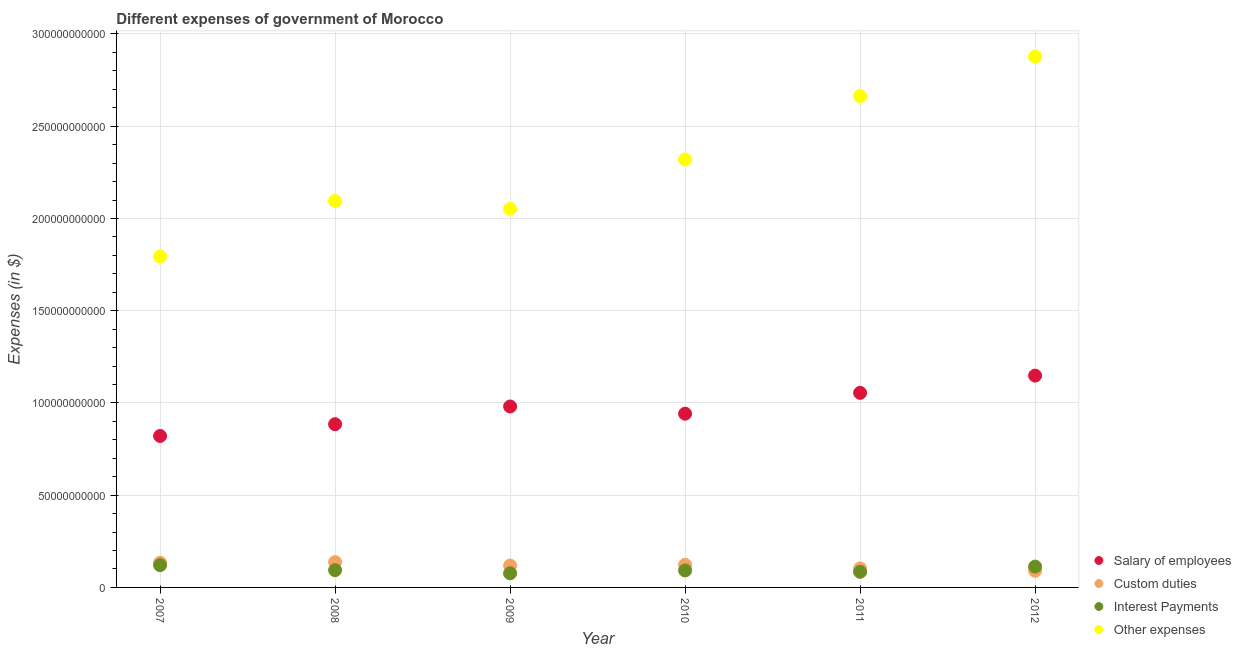Is the number of dotlines equal to the number of legend labels?
Keep it short and to the point. Yes. What is the amount spent on other expenses in 2009?
Provide a short and direct response. 2.05e+11. Across all years, what is the maximum amount spent on salary of employees?
Keep it short and to the point. 1.15e+11. Across all years, what is the minimum amount spent on salary of employees?
Give a very brief answer. 8.21e+1. In which year was the amount spent on other expenses maximum?
Provide a succinct answer. 2012. In which year was the amount spent on salary of employees minimum?
Provide a succinct answer. 2007. What is the total amount spent on interest payments in the graph?
Provide a succinct answer. 5.80e+1. What is the difference between the amount spent on custom duties in 2007 and that in 2012?
Ensure brevity in your answer.  4.41e+09. What is the difference between the amount spent on other expenses in 2007 and the amount spent on custom duties in 2010?
Your response must be concise. 1.67e+11. What is the average amount spent on other expenses per year?
Your response must be concise. 2.30e+11. In the year 2010, what is the difference between the amount spent on custom duties and amount spent on salary of employees?
Ensure brevity in your answer.  -8.19e+1. What is the ratio of the amount spent on interest payments in 2008 to that in 2009?
Keep it short and to the point. 1.22. Is the amount spent on other expenses in 2011 less than that in 2012?
Provide a short and direct response. Yes. Is the difference between the amount spent on salary of employees in 2009 and 2012 greater than the difference between the amount spent on custom duties in 2009 and 2012?
Provide a succinct answer. No. What is the difference between the highest and the second highest amount spent on custom duties?
Offer a very short reply. 2.91e+08. What is the difference between the highest and the lowest amount spent on salary of employees?
Provide a short and direct response. 3.27e+1. In how many years, is the amount spent on salary of employees greater than the average amount spent on salary of employees taken over all years?
Ensure brevity in your answer.  3. Is it the case that in every year, the sum of the amount spent on salary of employees and amount spent on custom duties is greater than the amount spent on interest payments?
Offer a terse response. Yes. Is the amount spent on salary of employees strictly less than the amount spent on custom duties over the years?
Your answer should be compact. No. How many dotlines are there?
Keep it short and to the point. 4. What is the difference between two consecutive major ticks on the Y-axis?
Provide a short and direct response. 5.00e+1. Are the values on the major ticks of Y-axis written in scientific E-notation?
Ensure brevity in your answer.  No. Does the graph contain any zero values?
Ensure brevity in your answer.  No. Does the graph contain grids?
Offer a very short reply. Yes. Where does the legend appear in the graph?
Keep it short and to the point. Bottom right. How are the legend labels stacked?
Ensure brevity in your answer.  Vertical. What is the title of the graph?
Make the answer very short. Different expenses of government of Morocco. What is the label or title of the Y-axis?
Offer a terse response. Expenses (in $). What is the Expenses (in $) in Salary of employees in 2007?
Your answer should be very brief. 8.21e+1. What is the Expenses (in $) in Custom duties in 2007?
Ensure brevity in your answer.  1.34e+1. What is the Expenses (in $) in Interest Payments in 2007?
Offer a terse response. 1.21e+1. What is the Expenses (in $) in Other expenses in 2007?
Offer a very short reply. 1.79e+11. What is the Expenses (in $) of Salary of employees in 2008?
Your response must be concise. 8.85e+1. What is the Expenses (in $) in Custom duties in 2008?
Give a very brief answer. 1.37e+1. What is the Expenses (in $) in Interest Payments in 2008?
Make the answer very short. 9.35e+09. What is the Expenses (in $) of Other expenses in 2008?
Your answer should be compact. 2.09e+11. What is the Expenses (in $) of Salary of employees in 2009?
Keep it short and to the point. 9.81e+1. What is the Expenses (in $) in Custom duties in 2009?
Keep it short and to the point. 1.18e+1. What is the Expenses (in $) of Interest Payments in 2009?
Your response must be concise. 7.66e+09. What is the Expenses (in $) of Other expenses in 2009?
Your answer should be compact. 2.05e+11. What is the Expenses (in $) of Salary of employees in 2010?
Make the answer very short. 9.42e+1. What is the Expenses (in $) in Custom duties in 2010?
Your answer should be very brief. 1.23e+1. What is the Expenses (in $) in Interest Payments in 2010?
Offer a very short reply. 9.21e+09. What is the Expenses (in $) of Other expenses in 2010?
Ensure brevity in your answer.  2.32e+11. What is the Expenses (in $) in Salary of employees in 2011?
Provide a succinct answer. 1.05e+11. What is the Expenses (in $) in Custom duties in 2011?
Your answer should be compact. 1.03e+1. What is the Expenses (in $) in Interest Payments in 2011?
Your answer should be very brief. 8.45e+09. What is the Expenses (in $) in Other expenses in 2011?
Your answer should be compact. 2.66e+11. What is the Expenses (in $) in Salary of employees in 2012?
Offer a very short reply. 1.15e+11. What is the Expenses (in $) of Custom duties in 2012?
Ensure brevity in your answer.  9.00e+09. What is the Expenses (in $) of Interest Payments in 2012?
Ensure brevity in your answer.  1.13e+1. What is the Expenses (in $) of Other expenses in 2012?
Your answer should be compact. 2.88e+11. Across all years, what is the maximum Expenses (in $) of Salary of employees?
Provide a short and direct response. 1.15e+11. Across all years, what is the maximum Expenses (in $) of Custom duties?
Ensure brevity in your answer.  1.37e+1. Across all years, what is the maximum Expenses (in $) of Interest Payments?
Keep it short and to the point. 1.21e+1. Across all years, what is the maximum Expenses (in $) of Other expenses?
Your answer should be compact. 2.88e+11. Across all years, what is the minimum Expenses (in $) of Salary of employees?
Provide a short and direct response. 8.21e+1. Across all years, what is the minimum Expenses (in $) in Custom duties?
Your answer should be very brief. 9.00e+09. Across all years, what is the minimum Expenses (in $) in Interest Payments?
Give a very brief answer. 7.66e+09. Across all years, what is the minimum Expenses (in $) in Other expenses?
Your response must be concise. 1.79e+11. What is the total Expenses (in $) of Salary of employees in the graph?
Your answer should be very brief. 5.83e+11. What is the total Expenses (in $) in Custom duties in the graph?
Keep it short and to the point. 7.05e+1. What is the total Expenses (in $) in Interest Payments in the graph?
Provide a short and direct response. 5.80e+1. What is the total Expenses (in $) in Other expenses in the graph?
Provide a short and direct response. 1.38e+12. What is the difference between the Expenses (in $) in Salary of employees in 2007 and that in 2008?
Keep it short and to the point. -6.37e+09. What is the difference between the Expenses (in $) of Custom duties in 2007 and that in 2008?
Give a very brief answer. -2.91e+08. What is the difference between the Expenses (in $) in Interest Payments in 2007 and that in 2008?
Provide a short and direct response. 2.71e+09. What is the difference between the Expenses (in $) of Other expenses in 2007 and that in 2008?
Offer a very short reply. -3.00e+1. What is the difference between the Expenses (in $) in Salary of employees in 2007 and that in 2009?
Your answer should be very brief. -1.60e+1. What is the difference between the Expenses (in $) of Custom duties in 2007 and that in 2009?
Offer a very short reply. 1.59e+09. What is the difference between the Expenses (in $) of Interest Payments in 2007 and that in 2009?
Provide a succinct answer. 4.40e+09. What is the difference between the Expenses (in $) in Other expenses in 2007 and that in 2009?
Your response must be concise. -2.57e+1. What is the difference between the Expenses (in $) in Salary of employees in 2007 and that in 2010?
Ensure brevity in your answer.  -1.21e+1. What is the difference between the Expenses (in $) of Custom duties in 2007 and that in 2010?
Keep it short and to the point. 1.15e+09. What is the difference between the Expenses (in $) in Interest Payments in 2007 and that in 2010?
Make the answer very short. 2.86e+09. What is the difference between the Expenses (in $) of Other expenses in 2007 and that in 2010?
Your response must be concise. -5.25e+1. What is the difference between the Expenses (in $) in Salary of employees in 2007 and that in 2011?
Your answer should be compact. -2.34e+1. What is the difference between the Expenses (in $) of Custom duties in 2007 and that in 2011?
Make the answer very short. 3.13e+09. What is the difference between the Expenses (in $) of Interest Payments in 2007 and that in 2011?
Make the answer very short. 3.61e+09. What is the difference between the Expenses (in $) in Other expenses in 2007 and that in 2011?
Make the answer very short. -8.69e+1. What is the difference between the Expenses (in $) of Salary of employees in 2007 and that in 2012?
Give a very brief answer. -3.27e+1. What is the difference between the Expenses (in $) of Custom duties in 2007 and that in 2012?
Provide a short and direct response. 4.41e+09. What is the difference between the Expenses (in $) in Interest Payments in 2007 and that in 2012?
Offer a terse response. 7.71e+08. What is the difference between the Expenses (in $) of Other expenses in 2007 and that in 2012?
Offer a very short reply. -1.08e+11. What is the difference between the Expenses (in $) in Salary of employees in 2008 and that in 2009?
Make the answer very short. -9.61e+09. What is the difference between the Expenses (in $) of Custom duties in 2008 and that in 2009?
Keep it short and to the point. 1.88e+09. What is the difference between the Expenses (in $) in Interest Payments in 2008 and that in 2009?
Offer a terse response. 1.69e+09. What is the difference between the Expenses (in $) of Other expenses in 2008 and that in 2009?
Your answer should be compact. 4.27e+09. What is the difference between the Expenses (in $) of Salary of employees in 2008 and that in 2010?
Your response must be concise. -5.70e+09. What is the difference between the Expenses (in $) in Custom duties in 2008 and that in 2010?
Make the answer very short. 1.44e+09. What is the difference between the Expenses (in $) of Interest Payments in 2008 and that in 2010?
Your response must be concise. 1.45e+08. What is the difference between the Expenses (in $) of Other expenses in 2008 and that in 2010?
Your answer should be compact. -2.25e+1. What is the difference between the Expenses (in $) in Salary of employees in 2008 and that in 2011?
Your answer should be compact. -1.70e+1. What is the difference between the Expenses (in $) of Custom duties in 2008 and that in 2011?
Make the answer very short. 3.42e+09. What is the difference between the Expenses (in $) in Interest Payments in 2008 and that in 2011?
Keep it short and to the point. 8.96e+08. What is the difference between the Expenses (in $) in Other expenses in 2008 and that in 2011?
Provide a short and direct response. -5.68e+1. What is the difference between the Expenses (in $) in Salary of employees in 2008 and that in 2012?
Your response must be concise. -2.63e+1. What is the difference between the Expenses (in $) of Custom duties in 2008 and that in 2012?
Provide a succinct answer. 4.70e+09. What is the difference between the Expenses (in $) of Interest Payments in 2008 and that in 2012?
Give a very brief answer. -1.94e+09. What is the difference between the Expenses (in $) in Other expenses in 2008 and that in 2012?
Give a very brief answer. -7.82e+1. What is the difference between the Expenses (in $) of Salary of employees in 2009 and that in 2010?
Your answer should be very brief. 3.92e+09. What is the difference between the Expenses (in $) of Custom duties in 2009 and that in 2010?
Offer a terse response. -4.39e+08. What is the difference between the Expenses (in $) in Interest Payments in 2009 and that in 2010?
Your answer should be compact. -1.54e+09. What is the difference between the Expenses (in $) in Other expenses in 2009 and that in 2010?
Offer a terse response. -2.68e+1. What is the difference between the Expenses (in $) in Salary of employees in 2009 and that in 2011?
Provide a succinct answer. -7.38e+09. What is the difference between the Expenses (in $) in Custom duties in 2009 and that in 2011?
Offer a terse response. 1.54e+09. What is the difference between the Expenses (in $) in Interest Payments in 2009 and that in 2011?
Offer a very short reply. -7.90e+08. What is the difference between the Expenses (in $) of Other expenses in 2009 and that in 2011?
Your answer should be compact. -6.11e+1. What is the difference between the Expenses (in $) of Salary of employees in 2009 and that in 2012?
Provide a succinct answer. -1.67e+1. What is the difference between the Expenses (in $) of Custom duties in 2009 and that in 2012?
Keep it short and to the point. 2.83e+09. What is the difference between the Expenses (in $) in Interest Payments in 2009 and that in 2012?
Keep it short and to the point. -3.63e+09. What is the difference between the Expenses (in $) of Other expenses in 2009 and that in 2012?
Provide a succinct answer. -8.25e+1. What is the difference between the Expenses (in $) of Salary of employees in 2010 and that in 2011?
Your response must be concise. -1.13e+1. What is the difference between the Expenses (in $) of Custom duties in 2010 and that in 2011?
Give a very brief answer. 1.98e+09. What is the difference between the Expenses (in $) of Interest Payments in 2010 and that in 2011?
Make the answer very short. 7.52e+08. What is the difference between the Expenses (in $) in Other expenses in 2010 and that in 2011?
Offer a very short reply. -3.44e+1. What is the difference between the Expenses (in $) in Salary of employees in 2010 and that in 2012?
Keep it short and to the point. -2.06e+1. What is the difference between the Expenses (in $) of Custom duties in 2010 and that in 2012?
Provide a succinct answer. 3.27e+09. What is the difference between the Expenses (in $) of Interest Payments in 2010 and that in 2012?
Your response must be concise. -2.08e+09. What is the difference between the Expenses (in $) in Other expenses in 2010 and that in 2012?
Make the answer very short. -5.57e+1. What is the difference between the Expenses (in $) in Salary of employees in 2011 and that in 2012?
Your answer should be compact. -9.35e+09. What is the difference between the Expenses (in $) of Custom duties in 2011 and that in 2012?
Your answer should be compact. 1.28e+09. What is the difference between the Expenses (in $) of Interest Payments in 2011 and that in 2012?
Your answer should be compact. -2.84e+09. What is the difference between the Expenses (in $) of Other expenses in 2011 and that in 2012?
Your response must be concise. -2.14e+1. What is the difference between the Expenses (in $) in Salary of employees in 2007 and the Expenses (in $) in Custom duties in 2008?
Your response must be concise. 6.84e+1. What is the difference between the Expenses (in $) in Salary of employees in 2007 and the Expenses (in $) in Interest Payments in 2008?
Make the answer very short. 7.27e+1. What is the difference between the Expenses (in $) in Salary of employees in 2007 and the Expenses (in $) in Other expenses in 2008?
Your answer should be compact. -1.27e+11. What is the difference between the Expenses (in $) of Custom duties in 2007 and the Expenses (in $) of Interest Payments in 2008?
Ensure brevity in your answer.  4.06e+09. What is the difference between the Expenses (in $) in Custom duties in 2007 and the Expenses (in $) in Other expenses in 2008?
Ensure brevity in your answer.  -1.96e+11. What is the difference between the Expenses (in $) in Interest Payments in 2007 and the Expenses (in $) in Other expenses in 2008?
Give a very brief answer. -1.97e+11. What is the difference between the Expenses (in $) of Salary of employees in 2007 and the Expenses (in $) of Custom duties in 2009?
Provide a short and direct response. 7.03e+1. What is the difference between the Expenses (in $) of Salary of employees in 2007 and the Expenses (in $) of Interest Payments in 2009?
Ensure brevity in your answer.  7.44e+1. What is the difference between the Expenses (in $) in Salary of employees in 2007 and the Expenses (in $) in Other expenses in 2009?
Give a very brief answer. -1.23e+11. What is the difference between the Expenses (in $) of Custom duties in 2007 and the Expenses (in $) of Interest Payments in 2009?
Your answer should be very brief. 5.75e+09. What is the difference between the Expenses (in $) in Custom duties in 2007 and the Expenses (in $) in Other expenses in 2009?
Give a very brief answer. -1.92e+11. What is the difference between the Expenses (in $) of Interest Payments in 2007 and the Expenses (in $) of Other expenses in 2009?
Your answer should be very brief. -1.93e+11. What is the difference between the Expenses (in $) of Salary of employees in 2007 and the Expenses (in $) of Custom duties in 2010?
Your answer should be very brief. 6.98e+1. What is the difference between the Expenses (in $) of Salary of employees in 2007 and the Expenses (in $) of Interest Payments in 2010?
Provide a succinct answer. 7.29e+1. What is the difference between the Expenses (in $) of Salary of employees in 2007 and the Expenses (in $) of Other expenses in 2010?
Give a very brief answer. -1.50e+11. What is the difference between the Expenses (in $) of Custom duties in 2007 and the Expenses (in $) of Interest Payments in 2010?
Offer a terse response. 4.21e+09. What is the difference between the Expenses (in $) of Custom duties in 2007 and the Expenses (in $) of Other expenses in 2010?
Give a very brief answer. -2.19e+11. What is the difference between the Expenses (in $) in Interest Payments in 2007 and the Expenses (in $) in Other expenses in 2010?
Make the answer very short. -2.20e+11. What is the difference between the Expenses (in $) in Salary of employees in 2007 and the Expenses (in $) in Custom duties in 2011?
Keep it short and to the point. 7.18e+1. What is the difference between the Expenses (in $) in Salary of employees in 2007 and the Expenses (in $) in Interest Payments in 2011?
Your answer should be very brief. 7.36e+1. What is the difference between the Expenses (in $) in Salary of employees in 2007 and the Expenses (in $) in Other expenses in 2011?
Your answer should be very brief. -1.84e+11. What is the difference between the Expenses (in $) of Custom duties in 2007 and the Expenses (in $) of Interest Payments in 2011?
Make the answer very short. 4.96e+09. What is the difference between the Expenses (in $) in Custom duties in 2007 and the Expenses (in $) in Other expenses in 2011?
Offer a terse response. -2.53e+11. What is the difference between the Expenses (in $) in Interest Payments in 2007 and the Expenses (in $) in Other expenses in 2011?
Ensure brevity in your answer.  -2.54e+11. What is the difference between the Expenses (in $) of Salary of employees in 2007 and the Expenses (in $) of Custom duties in 2012?
Give a very brief answer. 7.31e+1. What is the difference between the Expenses (in $) in Salary of employees in 2007 and the Expenses (in $) in Interest Payments in 2012?
Provide a succinct answer. 7.08e+1. What is the difference between the Expenses (in $) of Salary of employees in 2007 and the Expenses (in $) of Other expenses in 2012?
Your answer should be compact. -2.06e+11. What is the difference between the Expenses (in $) in Custom duties in 2007 and the Expenses (in $) in Interest Payments in 2012?
Make the answer very short. 2.12e+09. What is the difference between the Expenses (in $) in Custom duties in 2007 and the Expenses (in $) in Other expenses in 2012?
Keep it short and to the point. -2.74e+11. What is the difference between the Expenses (in $) in Interest Payments in 2007 and the Expenses (in $) in Other expenses in 2012?
Ensure brevity in your answer.  -2.76e+11. What is the difference between the Expenses (in $) of Salary of employees in 2008 and the Expenses (in $) of Custom duties in 2009?
Provide a short and direct response. 7.66e+1. What is the difference between the Expenses (in $) in Salary of employees in 2008 and the Expenses (in $) in Interest Payments in 2009?
Your response must be concise. 8.08e+1. What is the difference between the Expenses (in $) in Salary of employees in 2008 and the Expenses (in $) in Other expenses in 2009?
Give a very brief answer. -1.17e+11. What is the difference between the Expenses (in $) of Custom duties in 2008 and the Expenses (in $) of Interest Payments in 2009?
Provide a short and direct response. 6.04e+09. What is the difference between the Expenses (in $) in Custom duties in 2008 and the Expenses (in $) in Other expenses in 2009?
Make the answer very short. -1.92e+11. What is the difference between the Expenses (in $) of Interest Payments in 2008 and the Expenses (in $) of Other expenses in 2009?
Make the answer very short. -1.96e+11. What is the difference between the Expenses (in $) in Salary of employees in 2008 and the Expenses (in $) in Custom duties in 2010?
Provide a succinct answer. 7.62e+1. What is the difference between the Expenses (in $) of Salary of employees in 2008 and the Expenses (in $) of Interest Payments in 2010?
Ensure brevity in your answer.  7.93e+1. What is the difference between the Expenses (in $) in Salary of employees in 2008 and the Expenses (in $) in Other expenses in 2010?
Provide a short and direct response. -1.43e+11. What is the difference between the Expenses (in $) of Custom duties in 2008 and the Expenses (in $) of Interest Payments in 2010?
Provide a succinct answer. 4.50e+09. What is the difference between the Expenses (in $) in Custom duties in 2008 and the Expenses (in $) in Other expenses in 2010?
Your response must be concise. -2.18e+11. What is the difference between the Expenses (in $) in Interest Payments in 2008 and the Expenses (in $) in Other expenses in 2010?
Provide a succinct answer. -2.23e+11. What is the difference between the Expenses (in $) of Salary of employees in 2008 and the Expenses (in $) of Custom duties in 2011?
Make the answer very short. 7.82e+1. What is the difference between the Expenses (in $) in Salary of employees in 2008 and the Expenses (in $) in Interest Payments in 2011?
Keep it short and to the point. 8.00e+1. What is the difference between the Expenses (in $) in Salary of employees in 2008 and the Expenses (in $) in Other expenses in 2011?
Ensure brevity in your answer.  -1.78e+11. What is the difference between the Expenses (in $) of Custom duties in 2008 and the Expenses (in $) of Interest Payments in 2011?
Your answer should be compact. 5.25e+09. What is the difference between the Expenses (in $) of Custom duties in 2008 and the Expenses (in $) of Other expenses in 2011?
Your answer should be compact. -2.53e+11. What is the difference between the Expenses (in $) in Interest Payments in 2008 and the Expenses (in $) in Other expenses in 2011?
Keep it short and to the point. -2.57e+11. What is the difference between the Expenses (in $) in Salary of employees in 2008 and the Expenses (in $) in Custom duties in 2012?
Keep it short and to the point. 7.95e+1. What is the difference between the Expenses (in $) of Salary of employees in 2008 and the Expenses (in $) of Interest Payments in 2012?
Provide a succinct answer. 7.72e+1. What is the difference between the Expenses (in $) in Salary of employees in 2008 and the Expenses (in $) in Other expenses in 2012?
Give a very brief answer. -1.99e+11. What is the difference between the Expenses (in $) in Custom duties in 2008 and the Expenses (in $) in Interest Payments in 2012?
Offer a terse response. 2.42e+09. What is the difference between the Expenses (in $) in Custom duties in 2008 and the Expenses (in $) in Other expenses in 2012?
Provide a short and direct response. -2.74e+11. What is the difference between the Expenses (in $) in Interest Payments in 2008 and the Expenses (in $) in Other expenses in 2012?
Your response must be concise. -2.78e+11. What is the difference between the Expenses (in $) in Salary of employees in 2009 and the Expenses (in $) in Custom duties in 2010?
Offer a terse response. 8.58e+1. What is the difference between the Expenses (in $) of Salary of employees in 2009 and the Expenses (in $) of Interest Payments in 2010?
Your answer should be very brief. 8.89e+1. What is the difference between the Expenses (in $) in Salary of employees in 2009 and the Expenses (in $) in Other expenses in 2010?
Ensure brevity in your answer.  -1.34e+11. What is the difference between the Expenses (in $) in Custom duties in 2009 and the Expenses (in $) in Interest Payments in 2010?
Provide a short and direct response. 2.62e+09. What is the difference between the Expenses (in $) in Custom duties in 2009 and the Expenses (in $) in Other expenses in 2010?
Your response must be concise. -2.20e+11. What is the difference between the Expenses (in $) in Interest Payments in 2009 and the Expenses (in $) in Other expenses in 2010?
Your answer should be very brief. -2.24e+11. What is the difference between the Expenses (in $) of Salary of employees in 2009 and the Expenses (in $) of Custom duties in 2011?
Your answer should be very brief. 8.78e+1. What is the difference between the Expenses (in $) in Salary of employees in 2009 and the Expenses (in $) in Interest Payments in 2011?
Give a very brief answer. 8.96e+1. What is the difference between the Expenses (in $) in Salary of employees in 2009 and the Expenses (in $) in Other expenses in 2011?
Keep it short and to the point. -1.68e+11. What is the difference between the Expenses (in $) in Custom duties in 2009 and the Expenses (in $) in Interest Payments in 2011?
Keep it short and to the point. 3.38e+09. What is the difference between the Expenses (in $) in Custom duties in 2009 and the Expenses (in $) in Other expenses in 2011?
Ensure brevity in your answer.  -2.54e+11. What is the difference between the Expenses (in $) in Interest Payments in 2009 and the Expenses (in $) in Other expenses in 2011?
Keep it short and to the point. -2.59e+11. What is the difference between the Expenses (in $) in Salary of employees in 2009 and the Expenses (in $) in Custom duties in 2012?
Keep it short and to the point. 8.91e+1. What is the difference between the Expenses (in $) of Salary of employees in 2009 and the Expenses (in $) of Interest Payments in 2012?
Offer a terse response. 8.68e+1. What is the difference between the Expenses (in $) of Salary of employees in 2009 and the Expenses (in $) of Other expenses in 2012?
Your response must be concise. -1.90e+11. What is the difference between the Expenses (in $) in Custom duties in 2009 and the Expenses (in $) in Interest Payments in 2012?
Provide a short and direct response. 5.39e+08. What is the difference between the Expenses (in $) of Custom duties in 2009 and the Expenses (in $) of Other expenses in 2012?
Ensure brevity in your answer.  -2.76e+11. What is the difference between the Expenses (in $) of Interest Payments in 2009 and the Expenses (in $) of Other expenses in 2012?
Ensure brevity in your answer.  -2.80e+11. What is the difference between the Expenses (in $) of Salary of employees in 2010 and the Expenses (in $) of Custom duties in 2011?
Your response must be concise. 8.39e+1. What is the difference between the Expenses (in $) of Salary of employees in 2010 and the Expenses (in $) of Interest Payments in 2011?
Keep it short and to the point. 8.57e+1. What is the difference between the Expenses (in $) of Salary of employees in 2010 and the Expenses (in $) of Other expenses in 2011?
Ensure brevity in your answer.  -1.72e+11. What is the difference between the Expenses (in $) of Custom duties in 2010 and the Expenses (in $) of Interest Payments in 2011?
Ensure brevity in your answer.  3.81e+09. What is the difference between the Expenses (in $) in Custom duties in 2010 and the Expenses (in $) in Other expenses in 2011?
Your response must be concise. -2.54e+11. What is the difference between the Expenses (in $) in Interest Payments in 2010 and the Expenses (in $) in Other expenses in 2011?
Provide a short and direct response. -2.57e+11. What is the difference between the Expenses (in $) of Salary of employees in 2010 and the Expenses (in $) of Custom duties in 2012?
Your answer should be very brief. 8.52e+1. What is the difference between the Expenses (in $) of Salary of employees in 2010 and the Expenses (in $) of Interest Payments in 2012?
Make the answer very short. 8.29e+1. What is the difference between the Expenses (in $) of Salary of employees in 2010 and the Expenses (in $) of Other expenses in 2012?
Offer a very short reply. -1.94e+11. What is the difference between the Expenses (in $) of Custom duties in 2010 and the Expenses (in $) of Interest Payments in 2012?
Offer a very short reply. 9.78e+08. What is the difference between the Expenses (in $) in Custom duties in 2010 and the Expenses (in $) in Other expenses in 2012?
Provide a short and direct response. -2.75e+11. What is the difference between the Expenses (in $) of Interest Payments in 2010 and the Expenses (in $) of Other expenses in 2012?
Give a very brief answer. -2.78e+11. What is the difference between the Expenses (in $) in Salary of employees in 2011 and the Expenses (in $) in Custom duties in 2012?
Offer a very short reply. 9.65e+1. What is the difference between the Expenses (in $) of Salary of employees in 2011 and the Expenses (in $) of Interest Payments in 2012?
Your response must be concise. 9.42e+1. What is the difference between the Expenses (in $) of Salary of employees in 2011 and the Expenses (in $) of Other expenses in 2012?
Offer a terse response. -1.82e+11. What is the difference between the Expenses (in $) of Custom duties in 2011 and the Expenses (in $) of Interest Payments in 2012?
Your response must be concise. -1.00e+09. What is the difference between the Expenses (in $) in Custom duties in 2011 and the Expenses (in $) in Other expenses in 2012?
Make the answer very short. -2.77e+11. What is the difference between the Expenses (in $) of Interest Payments in 2011 and the Expenses (in $) of Other expenses in 2012?
Provide a succinct answer. -2.79e+11. What is the average Expenses (in $) in Salary of employees per year?
Give a very brief answer. 9.72e+1. What is the average Expenses (in $) of Custom duties per year?
Your response must be concise. 1.18e+1. What is the average Expenses (in $) in Interest Payments per year?
Your response must be concise. 9.67e+09. What is the average Expenses (in $) of Other expenses per year?
Keep it short and to the point. 2.30e+11. In the year 2007, what is the difference between the Expenses (in $) in Salary of employees and Expenses (in $) in Custom duties?
Provide a short and direct response. 6.87e+1. In the year 2007, what is the difference between the Expenses (in $) of Salary of employees and Expenses (in $) of Interest Payments?
Ensure brevity in your answer.  7.00e+1. In the year 2007, what is the difference between the Expenses (in $) of Salary of employees and Expenses (in $) of Other expenses?
Keep it short and to the point. -9.74e+1. In the year 2007, what is the difference between the Expenses (in $) of Custom duties and Expenses (in $) of Interest Payments?
Ensure brevity in your answer.  1.35e+09. In the year 2007, what is the difference between the Expenses (in $) of Custom duties and Expenses (in $) of Other expenses?
Ensure brevity in your answer.  -1.66e+11. In the year 2007, what is the difference between the Expenses (in $) of Interest Payments and Expenses (in $) of Other expenses?
Keep it short and to the point. -1.67e+11. In the year 2008, what is the difference between the Expenses (in $) in Salary of employees and Expenses (in $) in Custom duties?
Give a very brief answer. 7.48e+1. In the year 2008, what is the difference between the Expenses (in $) in Salary of employees and Expenses (in $) in Interest Payments?
Your response must be concise. 7.91e+1. In the year 2008, what is the difference between the Expenses (in $) of Salary of employees and Expenses (in $) of Other expenses?
Keep it short and to the point. -1.21e+11. In the year 2008, what is the difference between the Expenses (in $) of Custom duties and Expenses (in $) of Interest Payments?
Your answer should be compact. 4.36e+09. In the year 2008, what is the difference between the Expenses (in $) in Custom duties and Expenses (in $) in Other expenses?
Your response must be concise. -1.96e+11. In the year 2008, what is the difference between the Expenses (in $) in Interest Payments and Expenses (in $) in Other expenses?
Provide a succinct answer. -2.00e+11. In the year 2009, what is the difference between the Expenses (in $) in Salary of employees and Expenses (in $) in Custom duties?
Your answer should be very brief. 8.63e+1. In the year 2009, what is the difference between the Expenses (in $) of Salary of employees and Expenses (in $) of Interest Payments?
Your response must be concise. 9.04e+1. In the year 2009, what is the difference between the Expenses (in $) in Salary of employees and Expenses (in $) in Other expenses?
Your answer should be compact. -1.07e+11. In the year 2009, what is the difference between the Expenses (in $) in Custom duties and Expenses (in $) in Interest Payments?
Your answer should be very brief. 4.17e+09. In the year 2009, what is the difference between the Expenses (in $) of Custom duties and Expenses (in $) of Other expenses?
Keep it short and to the point. -1.93e+11. In the year 2009, what is the difference between the Expenses (in $) in Interest Payments and Expenses (in $) in Other expenses?
Provide a short and direct response. -1.98e+11. In the year 2010, what is the difference between the Expenses (in $) of Salary of employees and Expenses (in $) of Custom duties?
Give a very brief answer. 8.19e+1. In the year 2010, what is the difference between the Expenses (in $) of Salary of employees and Expenses (in $) of Interest Payments?
Make the answer very short. 8.50e+1. In the year 2010, what is the difference between the Expenses (in $) in Salary of employees and Expenses (in $) in Other expenses?
Your answer should be very brief. -1.38e+11. In the year 2010, what is the difference between the Expenses (in $) in Custom duties and Expenses (in $) in Interest Payments?
Keep it short and to the point. 3.06e+09. In the year 2010, what is the difference between the Expenses (in $) in Custom duties and Expenses (in $) in Other expenses?
Provide a short and direct response. -2.20e+11. In the year 2010, what is the difference between the Expenses (in $) of Interest Payments and Expenses (in $) of Other expenses?
Provide a succinct answer. -2.23e+11. In the year 2011, what is the difference between the Expenses (in $) in Salary of employees and Expenses (in $) in Custom duties?
Offer a very short reply. 9.52e+1. In the year 2011, what is the difference between the Expenses (in $) of Salary of employees and Expenses (in $) of Interest Payments?
Your answer should be very brief. 9.70e+1. In the year 2011, what is the difference between the Expenses (in $) in Salary of employees and Expenses (in $) in Other expenses?
Your answer should be very brief. -1.61e+11. In the year 2011, what is the difference between the Expenses (in $) of Custom duties and Expenses (in $) of Interest Payments?
Give a very brief answer. 1.83e+09. In the year 2011, what is the difference between the Expenses (in $) in Custom duties and Expenses (in $) in Other expenses?
Give a very brief answer. -2.56e+11. In the year 2011, what is the difference between the Expenses (in $) of Interest Payments and Expenses (in $) of Other expenses?
Give a very brief answer. -2.58e+11. In the year 2012, what is the difference between the Expenses (in $) of Salary of employees and Expenses (in $) of Custom duties?
Keep it short and to the point. 1.06e+11. In the year 2012, what is the difference between the Expenses (in $) in Salary of employees and Expenses (in $) in Interest Payments?
Make the answer very short. 1.04e+11. In the year 2012, what is the difference between the Expenses (in $) in Salary of employees and Expenses (in $) in Other expenses?
Your response must be concise. -1.73e+11. In the year 2012, what is the difference between the Expenses (in $) in Custom duties and Expenses (in $) in Interest Payments?
Keep it short and to the point. -2.29e+09. In the year 2012, what is the difference between the Expenses (in $) of Custom duties and Expenses (in $) of Other expenses?
Your answer should be very brief. -2.79e+11. In the year 2012, what is the difference between the Expenses (in $) in Interest Payments and Expenses (in $) in Other expenses?
Keep it short and to the point. -2.76e+11. What is the ratio of the Expenses (in $) in Salary of employees in 2007 to that in 2008?
Ensure brevity in your answer.  0.93. What is the ratio of the Expenses (in $) of Custom duties in 2007 to that in 2008?
Your response must be concise. 0.98. What is the ratio of the Expenses (in $) of Interest Payments in 2007 to that in 2008?
Offer a terse response. 1.29. What is the ratio of the Expenses (in $) in Other expenses in 2007 to that in 2008?
Ensure brevity in your answer.  0.86. What is the ratio of the Expenses (in $) of Salary of employees in 2007 to that in 2009?
Make the answer very short. 0.84. What is the ratio of the Expenses (in $) in Custom duties in 2007 to that in 2009?
Keep it short and to the point. 1.13. What is the ratio of the Expenses (in $) in Interest Payments in 2007 to that in 2009?
Make the answer very short. 1.57. What is the ratio of the Expenses (in $) in Other expenses in 2007 to that in 2009?
Ensure brevity in your answer.  0.87. What is the ratio of the Expenses (in $) of Salary of employees in 2007 to that in 2010?
Give a very brief answer. 0.87. What is the ratio of the Expenses (in $) in Custom duties in 2007 to that in 2010?
Offer a terse response. 1.09. What is the ratio of the Expenses (in $) in Interest Payments in 2007 to that in 2010?
Keep it short and to the point. 1.31. What is the ratio of the Expenses (in $) of Other expenses in 2007 to that in 2010?
Your answer should be compact. 0.77. What is the ratio of the Expenses (in $) of Salary of employees in 2007 to that in 2011?
Your answer should be compact. 0.78. What is the ratio of the Expenses (in $) in Custom duties in 2007 to that in 2011?
Your response must be concise. 1.3. What is the ratio of the Expenses (in $) in Interest Payments in 2007 to that in 2011?
Your answer should be very brief. 1.43. What is the ratio of the Expenses (in $) in Other expenses in 2007 to that in 2011?
Your answer should be compact. 0.67. What is the ratio of the Expenses (in $) in Salary of employees in 2007 to that in 2012?
Your answer should be very brief. 0.71. What is the ratio of the Expenses (in $) in Custom duties in 2007 to that in 2012?
Offer a very short reply. 1.49. What is the ratio of the Expenses (in $) of Interest Payments in 2007 to that in 2012?
Your response must be concise. 1.07. What is the ratio of the Expenses (in $) of Other expenses in 2007 to that in 2012?
Your answer should be very brief. 0.62. What is the ratio of the Expenses (in $) in Salary of employees in 2008 to that in 2009?
Your response must be concise. 0.9. What is the ratio of the Expenses (in $) of Custom duties in 2008 to that in 2009?
Keep it short and to the point. 1.16. What is the ratio of the Expenses (in $) of Interest Payments in 2008 to that in 2009?
Keep it short and to the point. 1.22. What is the ratio of the Expenses (in $) in Other expenses in 2008 to that in 2009?
Provide a succinct answer. 1.02. What is the ratio of the Expenses (in $) in Salary of employees in 2008 to that in 2010?
Your answer should be very brief. 0.94. What is the ratio of the Expenses (in $) in Custom duties in 2008 to that in 2010?
Provide a succinct answer. 1.12. What is the ratio of the Expenses (in $) in Interest Payments in 2008 to that in 2010?
Your response must be concise. 1.02. What is the ratio of the Expenses (in $) in Other expenses in 2008 to that in 2010?
Offer a very short reply. 0.9. What is the ratio of the Expenses (in $) in Salary of employees in 2008 to that in 2011?
Provide a short and direct response. 0.84. What is the ratio of the Expenses (in $) in Custom duties in 2008 to that in 2011?
Your answer should be very brief. 1.33. What is the ratio of the Expenses (in $) of Interest Payments in 2008 to that in 2011?
Keep it short and to the point. 1.11. What is the ratio of the Expenses (in $) of Other expenses in 2008 to that in 2011?
Offer a terse response. 0.79. What is the ratio of the Expenses (in $) of Salary of employees in 2008 to that in 2012?
Your answer should be very brief. 0.77. What is the ratio of the Expenses (in $) in Custom duties in 2008 to that in 2012?
Offer a terse response. 1.52. What is the ratio of the Expenses (in $) of Interest Payments in 2008 to that in 2012?
Your answer should be very brief. 0.83. What is the ratio of the Expenses (in $) in Other expenses in 2008 to that in 2012?
Ensure brevity in your answer.  0.73. What is the ratio of the Expenses (in $) of Salary of employees in 2009 to that in 2010?
Your answer should be compact. 1.04. What is the ratio of the Expenses (in $) in Custom duties in 2009 to that in 2010?
Provide a short and direct response. 0.96. What is the ratio of the Expenses (in $) of Interest Payments in 2009 to that in 2010?
Your answer should be very brief. 0.83. What is the ratio of the Expenses (in $) in Other expenses in 2009 to that in 2010?
Offer a very short reply. 0.88. What is the ratio of the Expenses (in $) of Salary of employees in 2009 to that in 2011?
Keep it short and to the point. 0.93. What is the ratio of the Expenses (in $) of Custom duties in 2009 to that in 2011?
Your answer should be compact. 1.15. What is the ratio of the Expenses (in $) in Interest Payments in 2009 to that in 2011?
Provide a short and direct response. 0.91. What is the ratio of the Expenses (in $) in Other expenses in 2009 to that in 2011?
Your answer should be very brief. 0.77. What is the ratio of the Expenses (in $) in Salary of employees in 2009 to that in 2012?
Your response must be concise. 0.85. What is the ratio of the Expenses (in $) in Custom duties in 2009 to that in 2012?
Your response must be concise. 1.31. What is the ratio of the Expenses (in $) of Interest Payments in 2009 to that in 2012?
Your response must be concise. 0.68. What is the ratio of the Expenses (in $) in Other expenses in 2009 to that in 2012?
Provide a succinct answer. 0.71. What is the ratio of the Expenses (in $) in Salary of employees in 2010 to that in 2011?
Provide a succinct answer. 0.89. What is the ratio of the Expenses (in $) in Custom duties in 2010 to that in 2011?
Provide a short and direct response. 1.19. What is the ratio of the Expenses (in $) of Interest Payments in 2010 to that in 2011?
Ensure brevity in your answer.  1.09. What is the ratio of the Expenses (in $) of Other expenses in 2010 to that in 2011?
Give a very brief answer. 0.87. What is the ratio of the Expenses (in $) in Salary of employees in 2010 to that in 2012?
Keep it short and to the point. 0.82. What is the ratio of the Expenses (in $) of Custom duties in 2010 to that in 2012?
Make the answer very short. 1.36. What is the ratio of the Expenses (in $) in Interest Payments in 2010 to that in 2012?
Provide a short and direct response. 0.82. What is the ratio of the Expenses (in $) of Other expenses in 2010 to that in 2012?
Your answer should be compact. 0.81. What is the ratio of the Expenses (in $) of Salary of employees in 2011 to that in 2012?
Give a very brief answer. 0.92. What is the ratio of the Expenses (in $) of Custom duties in 2011 to that in 2012?
Offer a very short reply. 1.14. What is the ratio of the Expenses (in $) in Interest Payments in 2011 to that in 2012?
Keep it short and to the point. 0.75. What is the ratio of the Expenses (in $) of Other expenses in 2011 to that in 2012?
Give a very brief answer. 0.93. What is the difference between the highest and the second highest Expenses (in $) of Salary of employees?
Ensure brevity in your answer.  9.35e+09. What is the difference between the highest and the second highest Expenses (in $) in Custom duties?
Offer a very short reply. 2.91e+08. What is the difference between the highest and the second highest Expenses (in $) in Interest Payments?
Your answer should be very brief. 7.71e+08. What is the difference between the highest and the second highest Expenses (in $) of Other expenses?
Keep it short and to the point. 2.14e+1. What is the difference between the highest and the lowest Expenses (in $) in Salary of employees?
Your response must be concise. 3.27e+1. What is the difference between the highest and the lowest Expenses (in $) of Custom duties?
Make the answer very short. 4.70e+09. What is the difference between the highest and the lowest Expenses (in $) in Interest Payments?
Make the answer very short. 4.40e+09. What is the difference between the highest and the lowest Expenses (in $) in Other expenses?
Offer a terse response. 1.08e+11. 